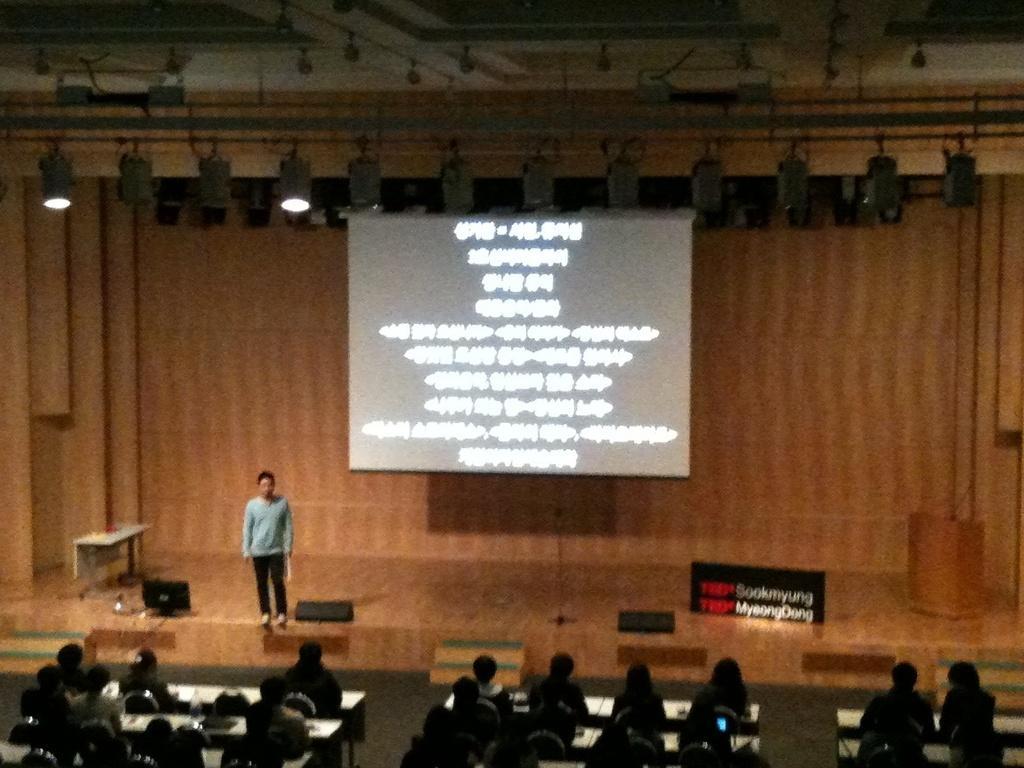How would you summarize this image in a sentence or two? In this image I can see number of persons are sitting on chairs in front of the desks. I can see the dais and on the days I can see a person standing, a podium, a table and in the background I can see the screen, the ceiling and few lights to the ceiling. 